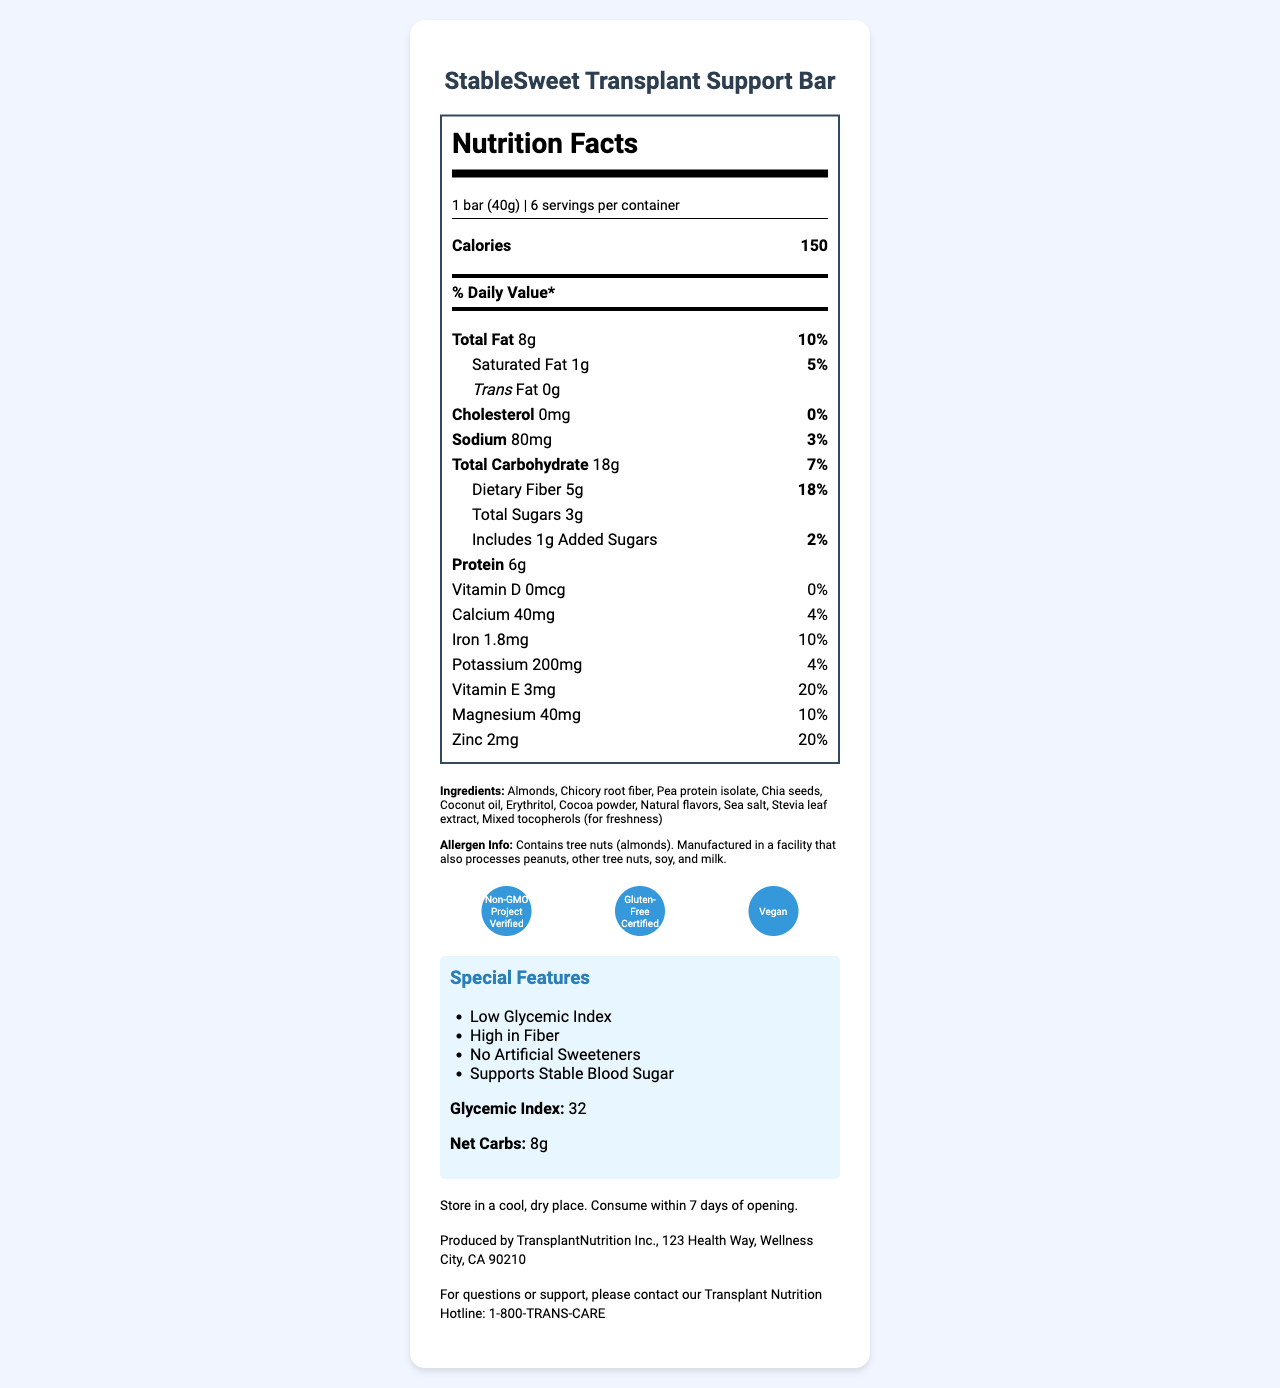what is the serving size of the StableSweet Transplant Support Bar? The serving size is listed as "1 bar (40g)" in the section detailing the serving information.
Answer: 1 bar (40g) how many servings are there per container? The document states that there are "6 servings per container."
Answer: 6 what percentage of the daily recommended intake of dietary fiber does one bar provide? The nutrient section indicates that each bar provides "5g" which corresponds to "18%" of the daily recommended intake of dietary fiber.
Answer: 18% how many grams of protein are in each bar? The amount of protein per serving is specifically listed as "6g" in the nutrient section.
Answer: 6g what is the calorie count per serving? The calorie count per serving is noted as "150 calories" in the nutrition facts section.
Answer: 150 calories which of these is not an ingredient in the StableSweet Transplant Support Bar? A. Almonds B. Peanuts C. Chia seeds D. Cocoa powder Peanuts are not listed under the ingredients, while almonds, chia seeds, and cocoa powder are.
Answer: B what special instruction is given for storage? The document states, "Store in a cool, dry place. Consume within 7 days of opening."
Answer: Store in a cool, dry place. Consume within 7 days of opening. does the StableSweet Transplant Support Bar contain any cholesterol? The document lists the cholesterol content as "0mg" with a daily value of "0%."
Answer: No what is the glycemic index of the snack bar? The glycemic index is specifically listed as "32."
Answer: 32 which certification does the StableSweet Transplant Support Bar have? A. USDA Organic B. Fair Trade Certified C. Non-GMO Project Verified D. Kosher Certified The snack bar is listed as having "Non-GMO Project Verified" certification among others, but not the other listed options.
Answer: C does this snack bar contain artificial sweeteners? The document states under special features that it has “No Artificial Sweeteners.”
Answer: No how much calcium does the snack bar contain? The document lists the calcium content as "40mg" with a daily value of "4%."
Answer: 40mg summarize the information provided in the document about the StableSweet Transplant Support Bar. The summary includes the main ingredients, nutritional information, certifications, and special features provided in the document.
Answer: The StableSweet Transplant Support Bar is designed to support stable blood sugar levels in pancreas transplant patients. Each bar weighs 40g and provides 150 calories, with significant amounts of dietary fiber (18% DV) and protein (6g). The product is low in glycemic index (32) and contains 8g of net carbs. It is free from cholesterol and artificial sweeteners and is certified non-GMO, gluten-free, and vegan. The bar's ingredients include almonds, chicory root fiber, and pea protein isolate. Special storage instructions advise keeping it in a cool, dry place and consuming it within 7 days of opening. what flavor options are available for the StableSweet Transplant Support Bar? The document does not provide any information about the available flavor options for the snack bar.
Answer: Cannot be determined 